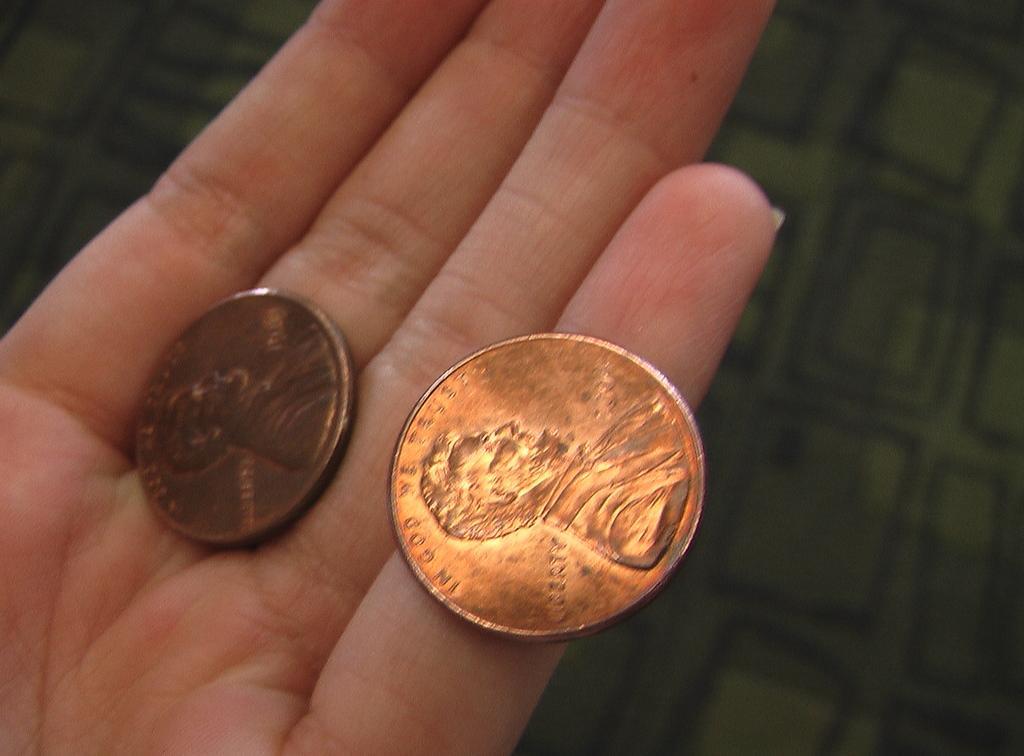Please provide a concise description of this image. In this picture we can see two coins on a person hand and in the background we can see a green color cloth. 